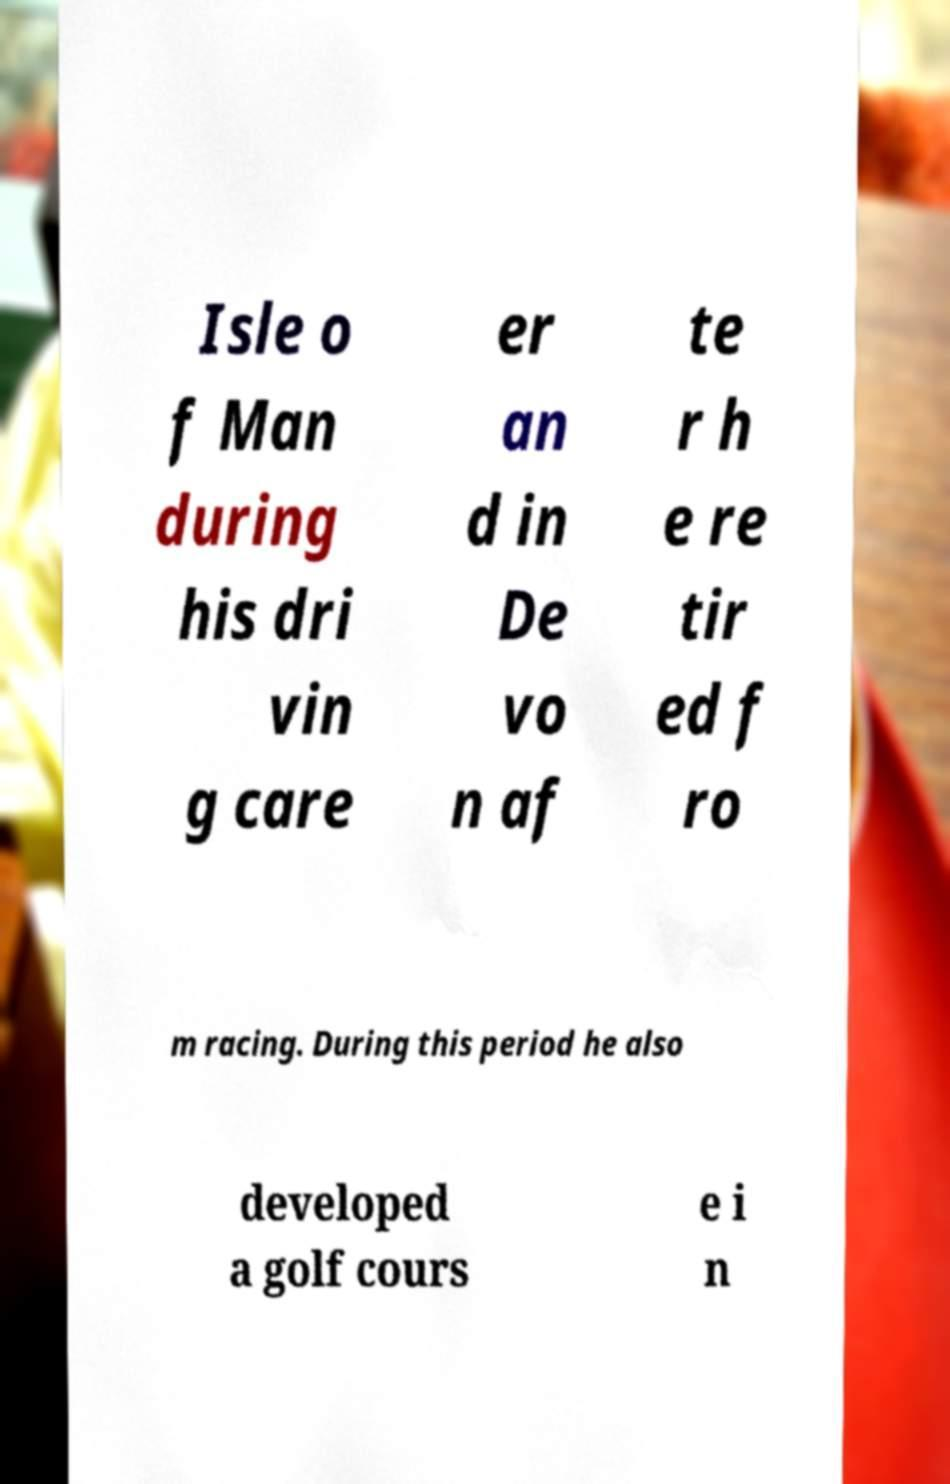What messages or text are displayed in this image? I need them in a readable, typed format. Isle o f Man during his dri vin g care er an d in De vo n af te r h e re tir ed f ro m racing. During this period he also developed a golf cours e i n 